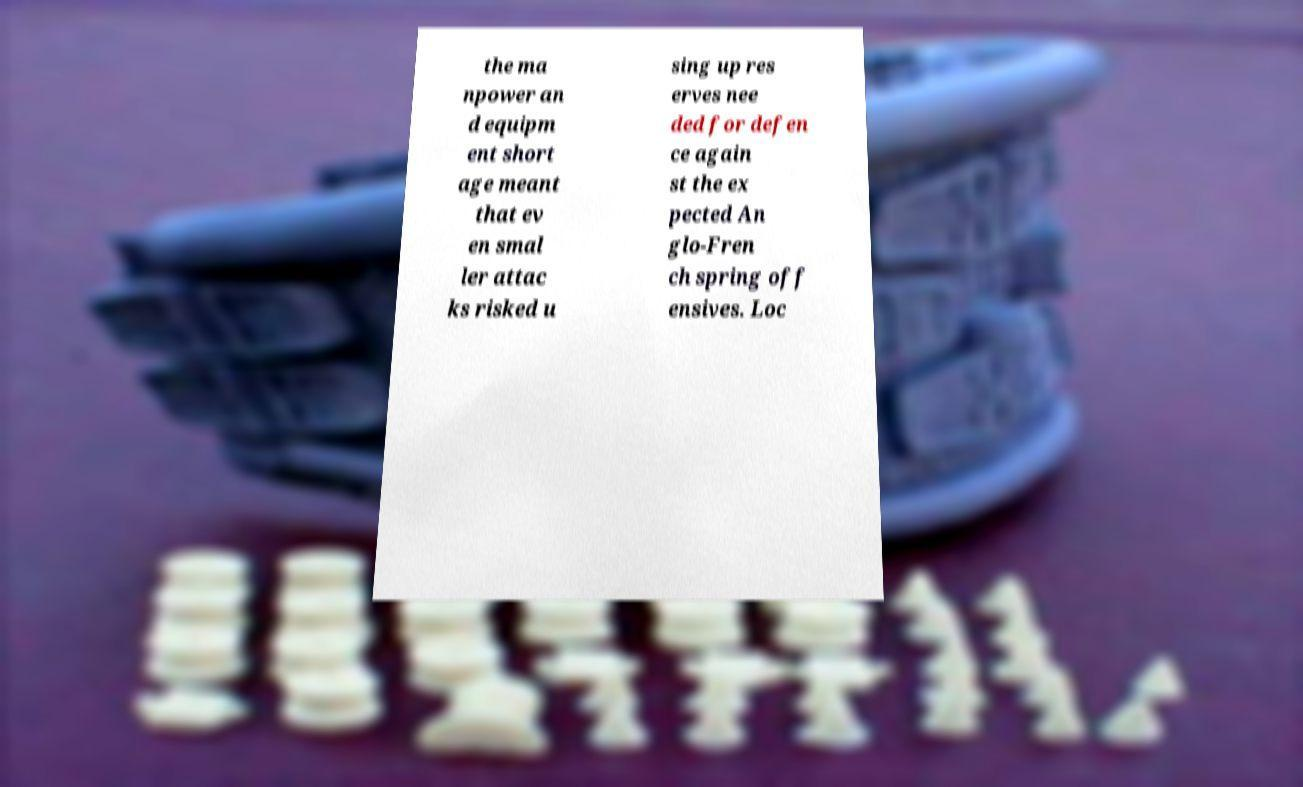Can you read and provide the text displayed in the image?This photo seems to have some interesting text. Can you extract and type it out for me? the ma npower an d equipm ent short age meant that ev en smal ler attac ks risked u sing up res erves nee ded for defen ce again st the ex pected An glo-Fren ch spring off ensives. Loc 